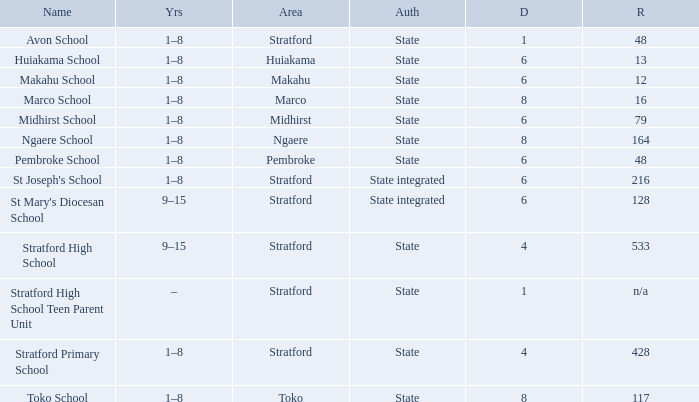What is the lowest decile with a state authority and Midhirst school? 6.0. 